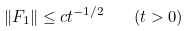<formula> <loc_0><loc_0><loc_500><loc_500>\| F _ { 1 } \| \leq c t ^ { - 1 / 2 } \quad ( t > 0 )</formula> 